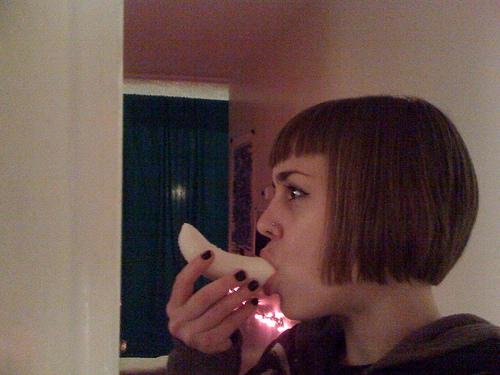Question: where was this photo taken?
Choices:
A. Living room.
B. Dining room.
C. Study.
D. Inside a person's home.
Answer with the letter. Answer: D Question: what view do we have of this person's face?
Choices:
A. Frontal.
B. A profile view.
C. Angled.
D. Upward.
Answer with the letter. Answer: B Question: what color are the curtains?
Choices:
A. Blue.
B. Red.
C. Brown.
D. Green.
Answer with the letter. Answer: A 